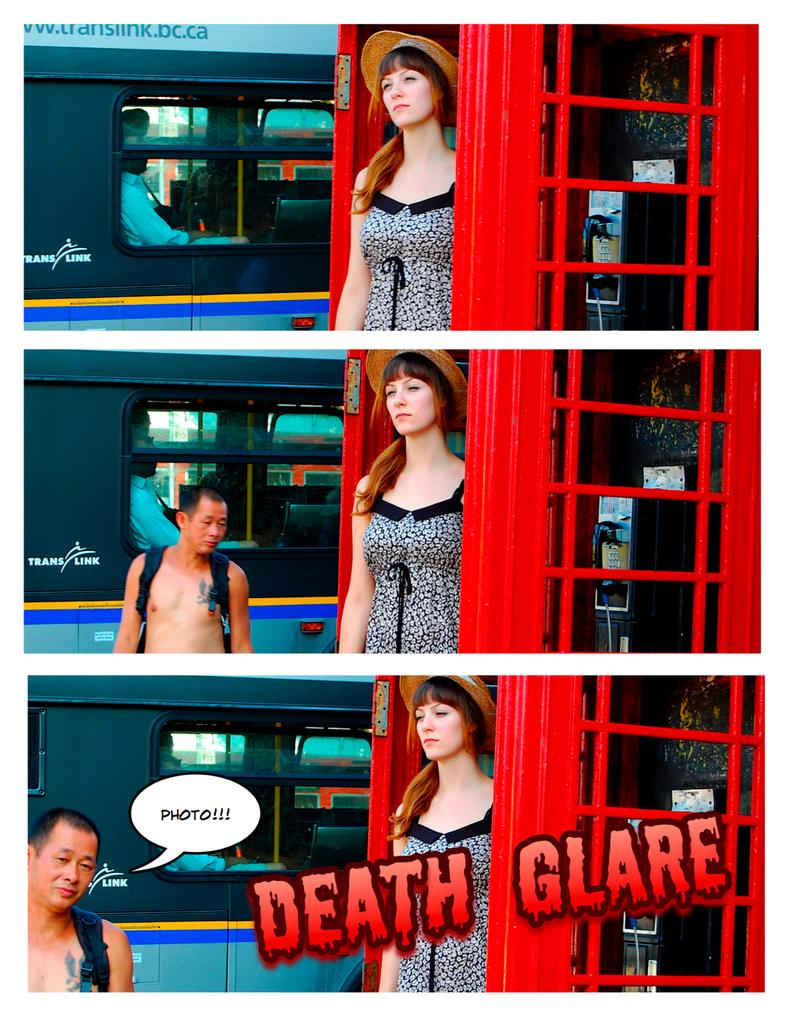How many people are in the image? There are two persons standing near a phone booth. What object is present in the image that is typically used for communication? There is a phone in the image. Can you describe the presence of a vehicle in the image? There is a person inside a vehicle in the image. What type of form is the person in the vehicle filling out in the image? There is no form present in the image; the person is simply inside a vehicle. What part of the body is the person in the vehicle using to say good-bye in the image? There is no indication of anyone saying good-bye in the image, and no body parts are visible in the vehicle. 